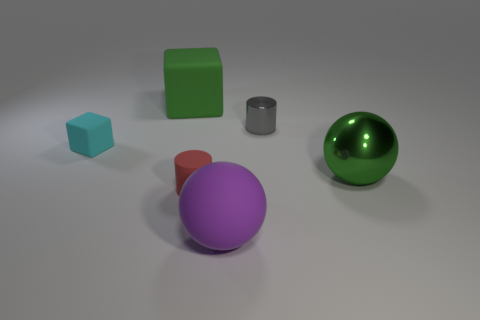Can you describe the textures of the objects shown? Certainly! The image displays objects with varying textures. The blue cube and the large green sphere have a smooth and shiny surface, reflecting the light with a bit of gloss. The red cylinder and the small grey cylinder appear to be matte, diffusing light softly without a glossy reflection. The purple sphere and the green cube seem to have an intermediate texture, not completely matte but with a subtle sheen. 